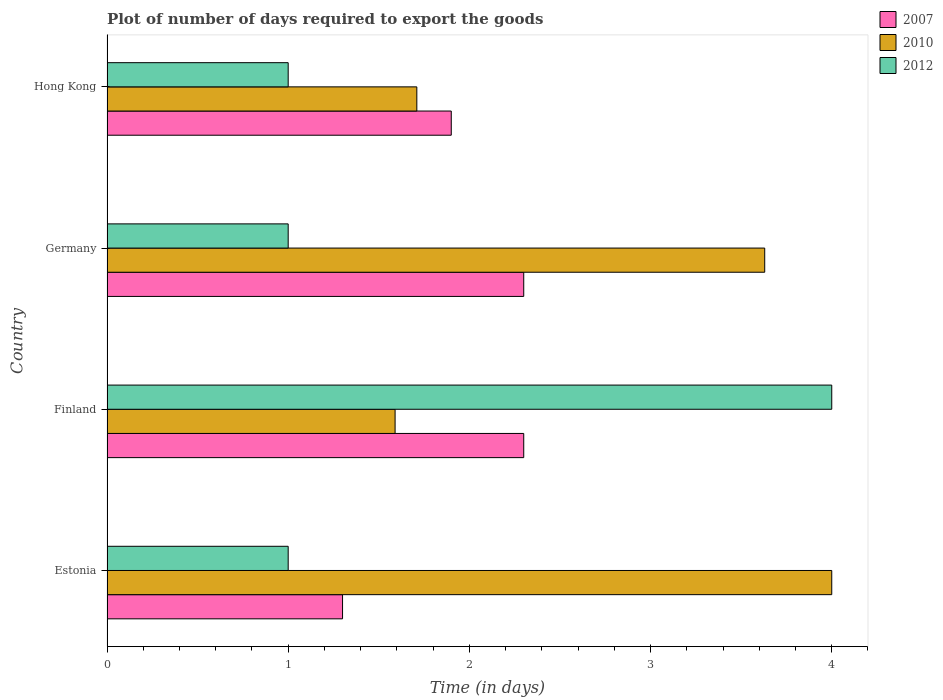How many groups of bars are there?
Provide a short and direct response. 4. How many bars are there on the 4th tick from the top?
Offer a terse response. 3. How many bars are there on the 1st tick from the bottom?
Offer a very short reply. 3. What is the time required to export goods in 2007 in Estonia?
Offer a very short reply. 1.3. Across all countries, what is the minimum time required to export goods in 2012?
Offer a very short reply. 1. In which country was the time required to export goods in 2010 maximum?
Your answer should be very brief. Estonia. What is the total time required to export goods in 2012 in the graph?
Provide a succinct answer. 7. What is the difference between the time required to export goods in 2010 in Finland and that in Germany?
Provide a short and direct response. -2.04. What is the difference between the time required to export goods in 2012 in Germany and the time required to export goods in 2007 in Finland?
Your response must be concise. -1.3. What is the difference between the time required to export goods in 2012 and time required to export goods in 2010 in Germany?
Your answer should be compact. -2.63. In how many countries, is the time required to export goods in 2012 greater than 2.6 days?
Your answer should be compact. 1. Is the difference between the time required to export goods in 2012 in Estonia and Hong Kong greater than the difference between the time required to export goods in 2010 in Estonia and Hong Kong?
Offer a very short reply. No. What is the difference between the highest and the second highest time required to export goods in 2010?
Your answer should be very brief. 0.37. What is the difference between the highest and the lowest time required to export goods in 2007?
Make the answer very short. 1. In how many countries, is the time required to export goods in 2007 greater than the average time required to export goods in 2007 taken over all countries?
Ensure brevity in your answer.  2. Is the sum of the time required to export goods in 2012 in Estonia and Finland greater than the maximum time required to export goods in 2007 across all countries?
Offer a terse response. Yes. What does the 2nd bar from the bottom in Germany represents?
Your response must be concise. 2010. Is it the case that in every country, the sum of the time required to export goods in 2010 and time required to export goods in 2012 is greater than the time required to export goods in 2007?
Ensure brevity in your answer.  Yes. How many countries are there in the graph?
Give a very brief answer. 4. Are the values on the major ticks of X-axis written in scientific E-notation?
Provide a succinct answer. No. Does the graph contain grids?
Your answer should be very brief. No. Where does the legend appear in the graph?
Your response must be concise. Top right. How many legend labels are there?
Your answer should be compact. 3. What is the title of the graph?
Offer a terse response. Plot of number of days required to export the goods. What is the label or title of the X-axis?
Your answer should be very brief. Time (in days). What is the Time (in days) in 2007 in Estonia?
Provide a succinct answer. 1.3. What is the Time (in days) in 2012 in Estonia?
Make the answer very short. 1. What is the Time (in days) in 2010 in Finland?
Your answer should be very brief. 1.59. What is the Time (in days) in 2010 in Germany?
Keep it short and to the point. 3.63. What is the Time (in days) of 2010 in Hong Kong?
Offer a terse response. 1.71. What is the Time (in days) in 2012 in Hong Kong?
Your answer should be very brief. 1. Across all countries, what is the maximum Time (in days) of 2012?
Keep it short and to the point. 4. Across all countries, what is the minimum Time (in days) of 2007?
Offer a terse response. 1.3. Across all countries, what is the minimum Time (in days) of 2010?
Offer a very short reply. 1.59. What is the total Time (in days) of 2010 in the graph?
Your answer should be very brief. 10.93. What is the total Time (in days) of 2012 in the graph?
Offer a terse response. 7. What is the difference between the Time (in days) in 2010 in Estonia and that in Finland?
Your answer should be very brief. 2.41. What is the difference between the Time (in days) of 2012 in Estonia and that in Finland?
Keep it short and to the point. -3. What is the difference between the Time (in days) of 2010 in Estonia and that in Germany?
Provide a short and direct response. 0.37. What is the difference between the Time (in days) of 2010 in Estonia and that in Hong Kong?
Offer a very short reply. 2.29. What is the difference between the Time (in days) of 2007 in Finland and that in Germany?
Provide a succinct answer. 0. What is the difference between the Time (in days) in 2010 in Finland and that in Germany?
Your response must be concise. -2.04. What is the difference between the Time (in days) of 2007 in Finland and that in Hong Kong?
Your response must be concise. 0.4. What is the difference between the Time (in days) in 2010 in Finland and that in Hong Kong?
Provide a short and direct response. -0.12. What is the difference between the Time (in days) of 2007 in Germany and that in Hong Kong?
Give a very brief answer. 0.4. What is the difference between the Time (in days) in 2010 in Germany and that in Hong Kong?
Give a very brief answer. 1.92. What is the difference between the Time (in days) in 2012 in Germany and that in Hong Kong?
Give a very brief answer. 0. What is the difference between the Time (in days) in 2007 in Estonia and the Time (in days) in 2010 in Finland?
Provide a succinct answer. -0.29. What is the difference between the Time (in days) in 2007 in Estonia and the Time (in days) in 2012 in Finland?
Your response must be concise. -2.7. What is the difference between the Time (in days) in 2010 in Estonia and the Time (in days) in 2012 in Finland?
Make the answer very short. 0. What is the difference between the Time (in days) in 2007 in Estonia and the Time (in days) in 2010 in Germany?
Offer a very short reply. -2.33. What is the difference between the Time (in days) in 2007 in Estonia and the Time (in days) in 2010 in Hong Kong?
Give a very brief answer. -0.41. What is the difference between the Time (in days) in 2007 in Estonia and the Time (in days) in 2012 in Hong Kong?
Your response must be concise. 0.3. What is the difference between the Time (in days) of 2007 in Finland and the Time (in days) of 2010 in Germany?
Offer a very short reply. -1.33. What is the difference between the Time (in days) in 2007 in Finland and the Time (in days) in 2012 in Germany?
Keep it short and to the point. 1.3. What is the difference between the Time (in days) in 2010 in Finland and the Time (in days) in 2012 in Germany?
Offer a terse response. 0.59. What is the difference between the Time (in days) in 2007 in Finland and the Time (in days) in 2010 in Hong Kong?
Provide a short and direct response. 0.59. What is the difference between the Time (in days) in 2010 in Finland and the Time (in days) in 2012 in Hong Kong?
Offer a terse response. 0.59. What is the difference between the Time (in days) in 2007 in Germany and the Time (in days) in 2010 in Hong Kong?
Make the answer very short. 0.59. What is the difference between the Time (in days) in 2010 in Germany and the Time (in days) in 2012 in Hong Kong?
Your answer should be very brief. 2.63. What is the average Time (in days) of 2007 per country?
Your answer should be compact. 1.95. What is the average Time (in days) of 2010 per country?
Give a very brief answer. 2.73. What is the average Time (in days) in 2012 per country?
Give a very brief answer. 1.75. What is the difference between the Time (in days) of 2010 and Time (in days) of 2012 in Estonia?
Provide a short and direct response. 3. What is the difference between the Time (in days) in 2007 and Time (in days) in 2010 in Finland?
Keep it short and to the point. 0.71. What is the difference between the Time (in days) in 2010 and Time (in days) in 2012 in Finland?
Make the answer very short. -2.41. What is the difference between the Time (in days) in 2007 and Time (in days) in 2010 in Germany?
Your answer should be very brief. -1.33. What is the difference between the Time (in days) in 2007 and Time (in days) in 2012 in Germany?
Make the answer very short. 1.3. What is the difference between the Time (in days) in 2010 and Time (in days) in 2012 in Germany?
Your response must be concise. 2.63. What is the difference between the Time (in days) of 2007 and Time (in days) of 2010 in Hong Kong?
Offer a very short reply. 0.19. What is the difference between the Time (in days) in 2010 and Time (in days) in 2012 in Hong Kong?
Your answer should be very brief. 0.71. What is the ratio of the Time (in days) in 2007 in Estonia to that in Finland?
Keep it short and to the point. 0.57. What is the ratio of the Time (in days) of 2010 in Estonia to that in Finland?
Provide a succinct answer. 2.52. What is the ratio of the Time (in days) in 2007 in Estonia to that in Germany?
Offer a terse response. 0.57. What is the ratio of the Time (in days) in 2010 in Estonia to that in Germany?
Keep it short and to the point. 1.1. What is the ratio of the Time (in days) of 2012 in Estonia to that in Germany?
Offer a very short reply. 1. What is the ratio of the Time (in days) of 2007 in Estonia to that in Hong Kong?
Your answer should be very brief. 0.68. What is the ratio of the Time (in days) in 2010 in Estonia to that in Hong Kong?
Give a very brief answer. 2.34. What is the ratio of the Time (in days) of 2007 in Finland to that in Germany?
Keep it short and to the point. 1. What is the ratio of the Time (in days) in 2010 in Finland to that in Germany?
Your response must be concise. 0.44. What is the ratio of the Time (in days) of 2012 in Finland to that in Germany?
Give a very brief answer. 4. What is the ratio of the Time (in days) of 2007 in Finland to that in Hong Kong?
Your answer should be very brief. 1.21. What is the ratio of the Time (in days) of 2010 in Finland to that in Hong Kong?
Give a very brief answer. 0.93. What is the ratio of the Time (in days) of 2012 in Finland to that in Hong Kong?
Provide a succinct answer. 4. What is the ratio of the Time (in days) of 2007 in Germany to that in Hong Kong?
Give a very brief answer. 1.21. What is the ratio of the Time (in days) of 2010 in Germany to that in Hong Kong?
Provide a succinct answer. 2.12. What is the ratio of the Time (in days) of 2012 in Germany to that in Hong Kong?
Provide a succinct answer. 1. What is the difference between the highest and the second highest Time (in days) in 2010?
Your answer should be very brief. 0.37. What is the difference between the highest and the lowest Time (in days) of 2010?
Your answer should be very brief. 2.41. 